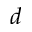Convert formula to latex. <formula><loc_0><loc_0><loc_500><loc_500>d</formula> 